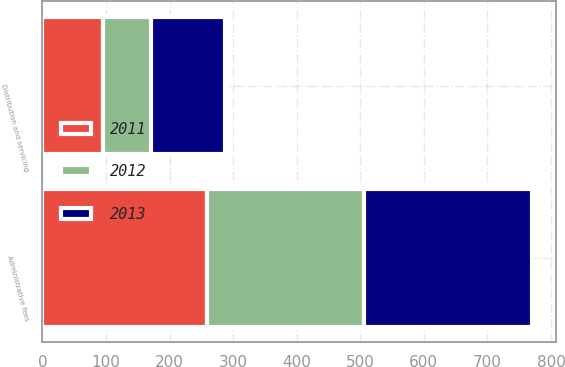<chart> <loc_0><loc_0><loc_500><loc_500><stacked_bar_chart><ecel><fcel>Administrative fees<fcel>Distribution and servicing<nl><fcel>2012<fcel>247<fcel>74.6<nl><fcel>2011<fcel>258.3<fcel>96.1<nl><fcel>2013<fcel>264.8<fcel>117.2<nl></chart> 